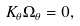<formula> <loc_0><loc_0><loc_500><loc_500>K _ { \theta } \Omega _ { \theta } = 0 ,</formula> 